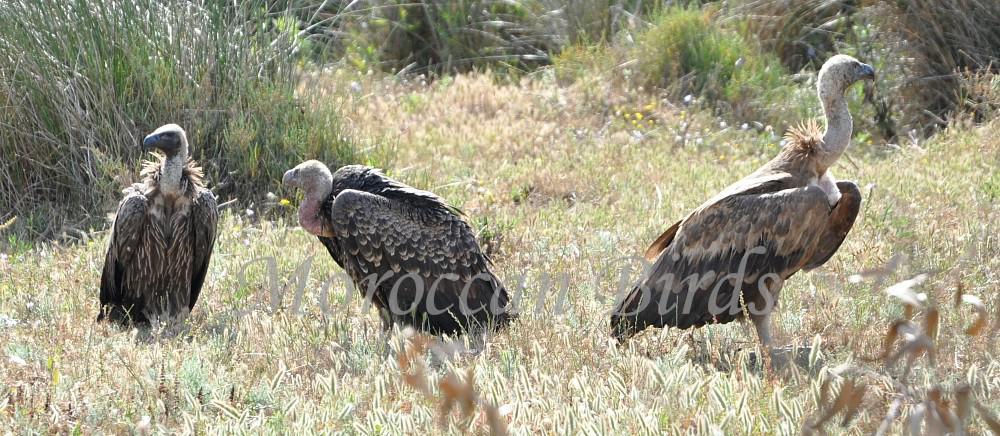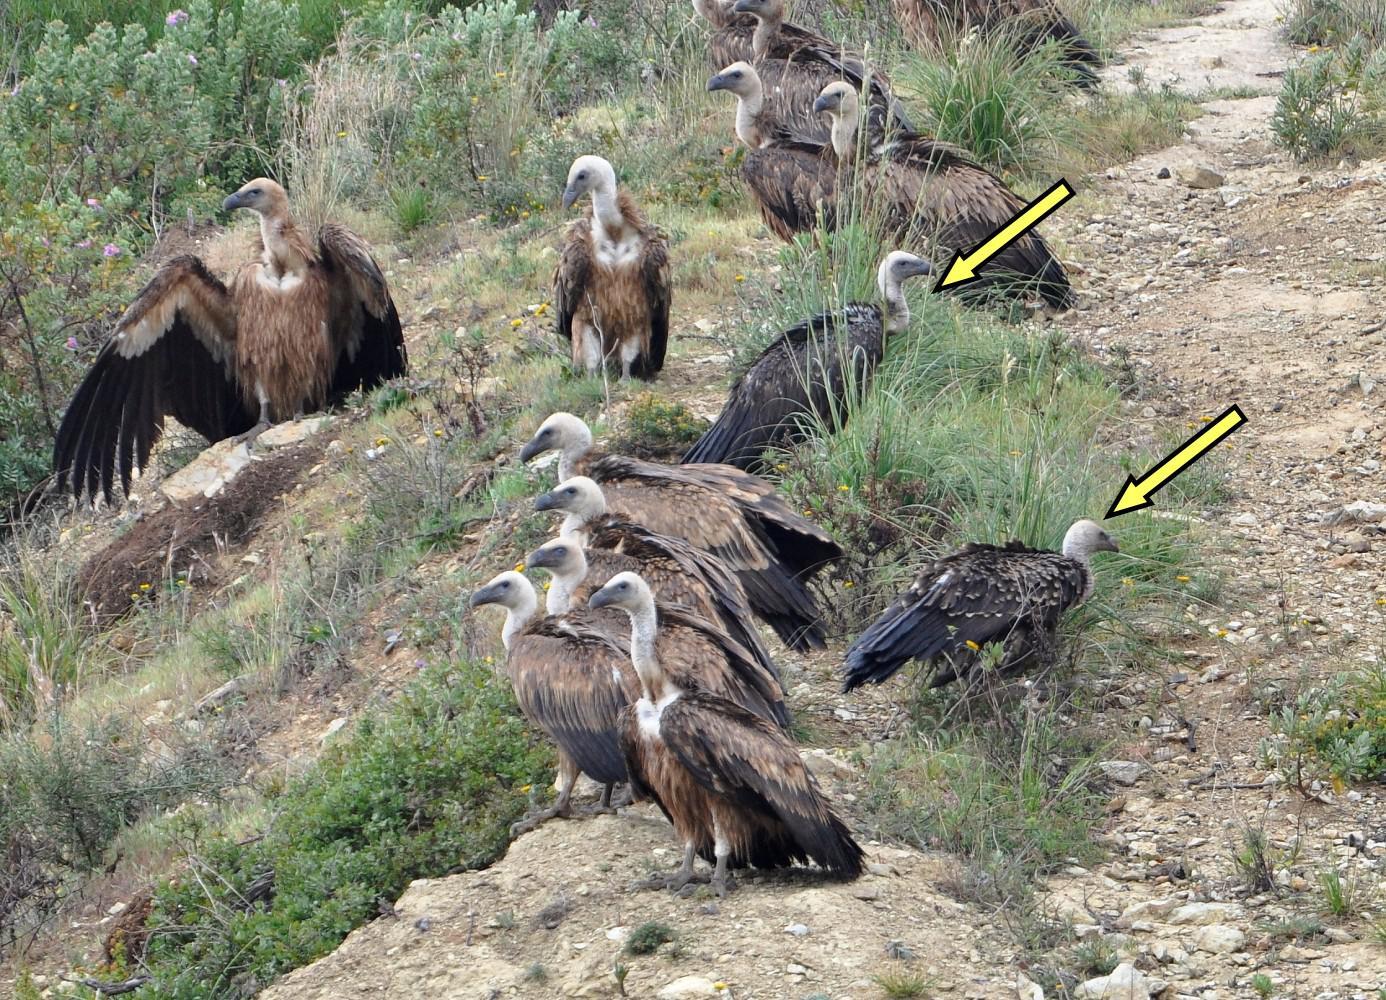The first image is the image on the left, the second image is the image on the right. Considering the images on both sides, is "There are more than four birds in the image to the right." valid? Answer yes or no. Yes. The first image is the image on the left, the second image is the image on the right. For the images displayed, is the sentence "a vulture has a tag on its left wing" factually correct? Answer yes or no. No. 